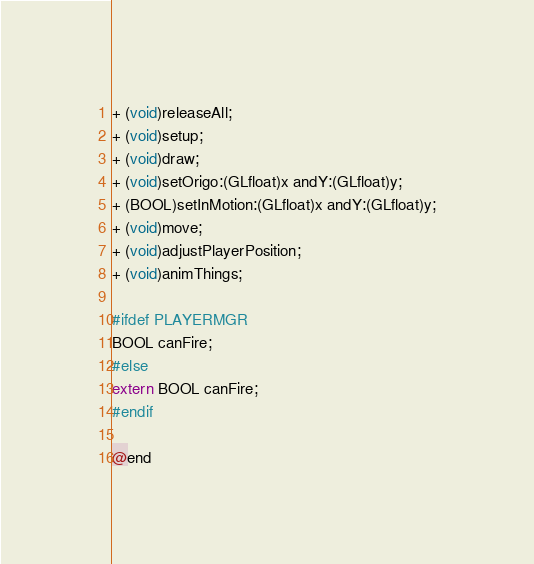Convert code to text. <code><loc_0><loc_0><loc_500><loc_500><_C_>+ (void)releaseAll;
+ (void)setup;
+ (void)draw;
+ (void)setOrigo:(GLfloat)x andY:(GLfloat)y;
+ (BOOL)setInMotion:(GLfloat)x andY:(GLfloat)y;
+ (void)move;
+ (void)adjustPlayerPosition;
+ (void)animThings;

#ifdef PLAYERMGR
BOOL canFire;
#else
extern BOOL canFire;
#endif

@end
</code> 